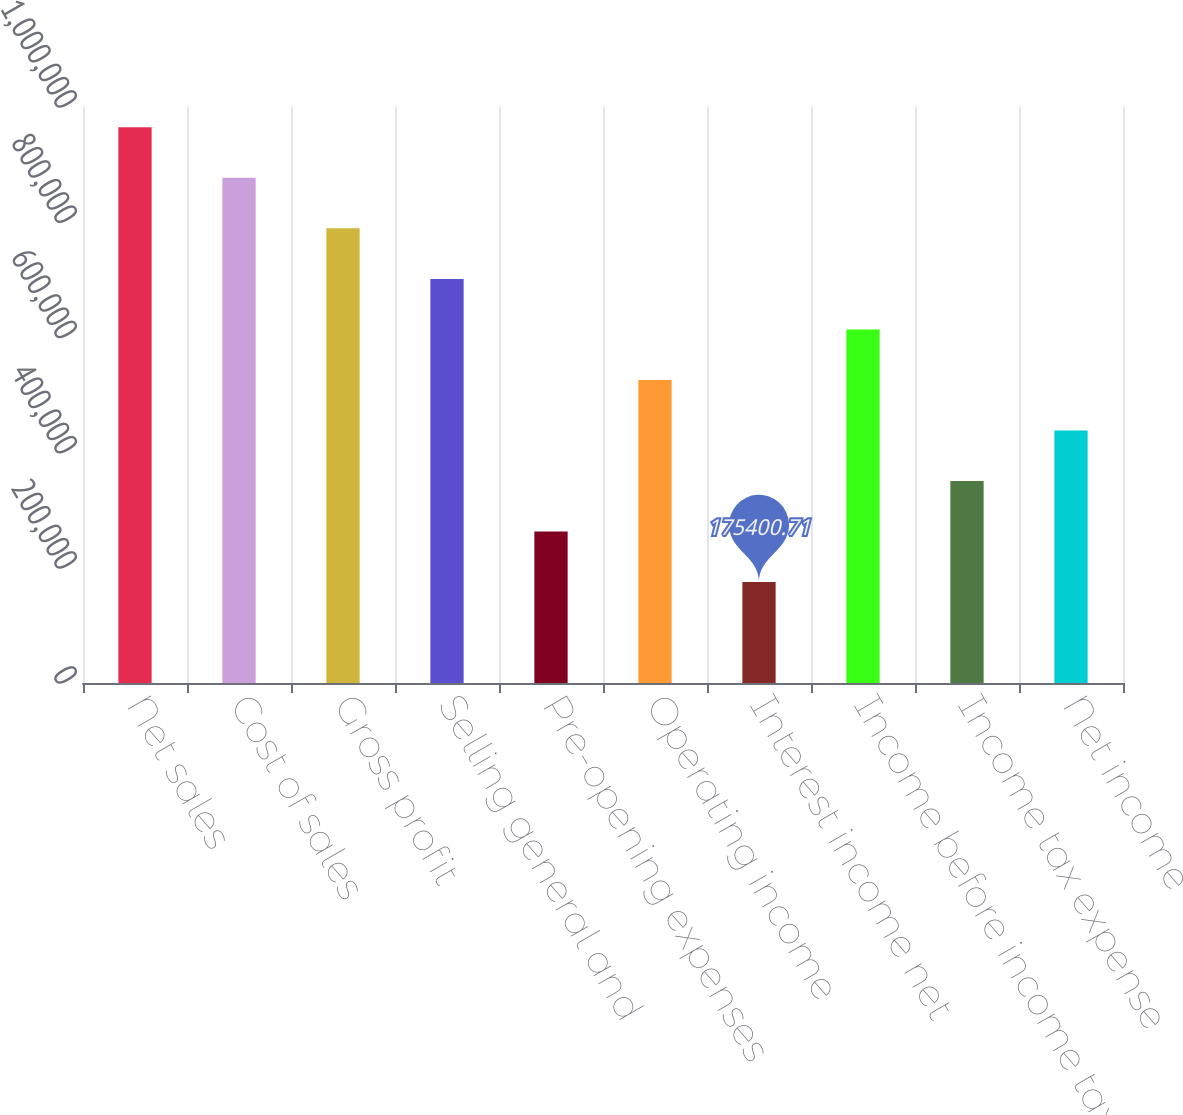Convert chart. <chart><loc_0><loc_0><loc_500><loc_500><bar_chart><fcel>Net sales<fcel>Cost of sales<fcel>Gross profit<fcel>Selling general and<fcel>Pre-opening expenses<fcel>Operating income<fcel>Interest income net<fcel>Income before income taxes<fcel>Income tax expense<fcel>Net income<nl><fcel>964699<fcel>876999<fcel>789299<fcel>701599<fcel>263100<fcel>526200<fcel>175401<fcel>613900<fcel>350800<fcel>438500<nl></chart> 